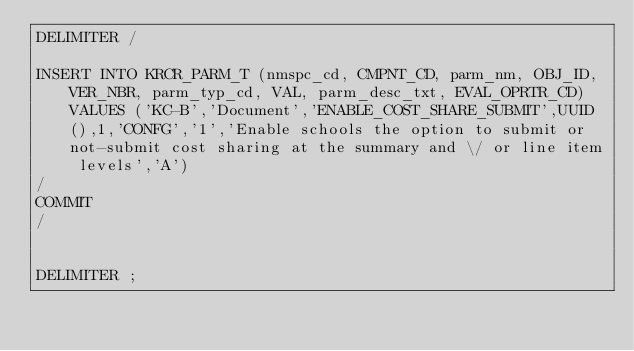Convert code to text. <code><loc_0><loc_0><loc_500><loc_500><_SQL_>DELIMITER /

INSERT INTO KRCR_PARM_T (nmspc_cd, CMPNT_CD, parm_nm, OBJ_ID, VER_NBR, parm_typ_cd, VAL, parm_desc_txt, EVAL_OPRTR_CD)  VALUES ('KC-B','Document','ENABLE_COST_SHARE_SUBMIT',UUID(),1,'CONFG','1','Enable schools the option to submit or not-submit cost sharing at the summary and \/ or line item levels','A')
/
COMMIT
/


DELIMITER ;
</code> 